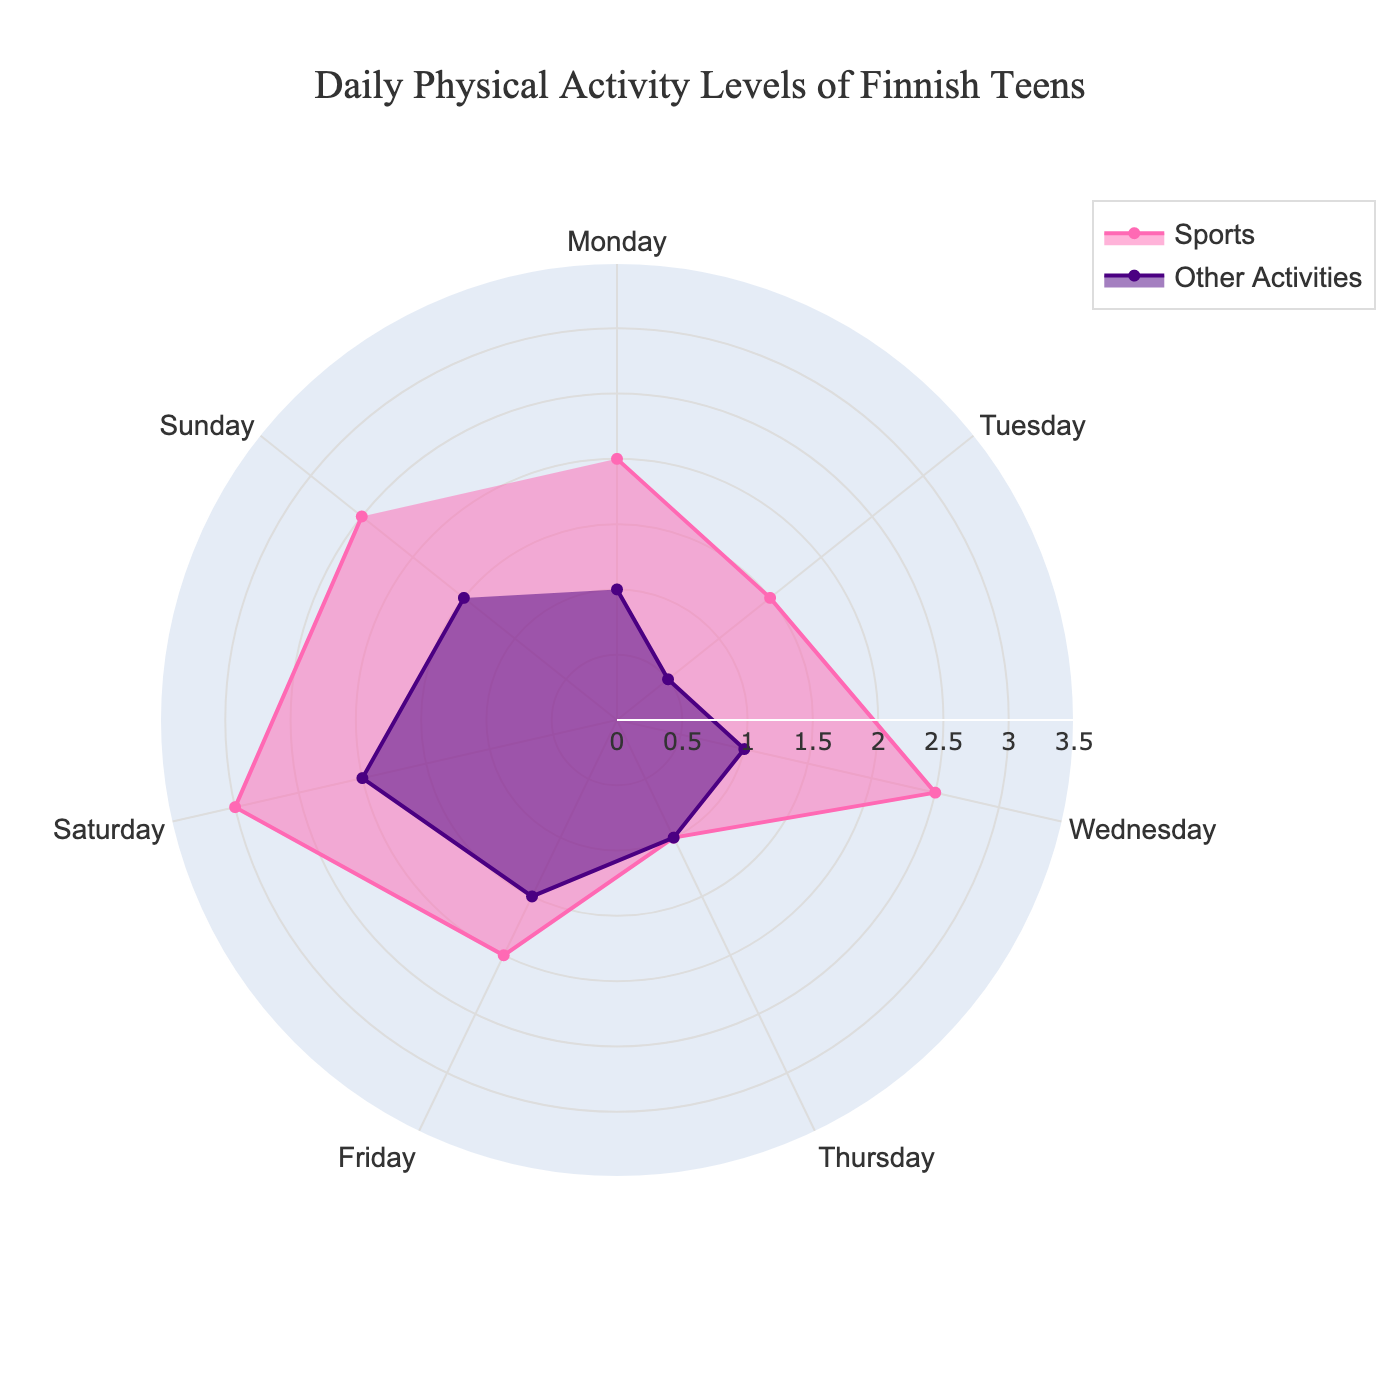what is the title of the plot? The title is displayed at the top center of the plot and provides an overview of what the chart represents.
Answer: Daily Physical Activity Levels of Finnish Teens What color is used to represent sports activities? The plot uses distinct colors to differentiate between sports and other activities. The color used for 'Sports' is identified by its visual appearance.
Answer: Pink On which day is the maximum time spent on sports? By comparing the radial distances for 'Sports' across all days, the day with the longest radial line represents the maximum time spent on sports.
Answer: Saturday How many hours are spent on other physical activities on Tuesday? By locating Tuesday on the angular axis and checking the radial value for 'Other Activities,' the time spent is observed.
Answer: 0.5 hours What is the average time spent on sports during the weekdays (Monday to Friday)? Sum the hours spent on sports from Monday to Friday and divide by 5 to find the average. (2 + 1.5 + 2.5 + 1 + 2)/5 = 9/5
Answer: 1.8 hours Which day has the least time spent in other physical activities? By finding the shortest radial distance for 'Other Activities,' we identify the day with the least amount of time spent.
Answer: Tuesday How much more time is spent on sports on Saturday compared to Thursday? Subtract the time spent on sports on Thursday from the time spent on sports on Saturday. 3 - 1
Answer: 2 hours Is the time spent in sports higher than other activities on all days? Compare the radial distances for 'Sports' and 'Other Activities' on each day to determine if the time spent on sports is consistently higher.
Answer: No What is the angular direction and period of the plot? The angular direction determines the sweep direction and the period denotes the number of divisions, which can be observed from the layout settings.
Answer: Clockwise, 7 